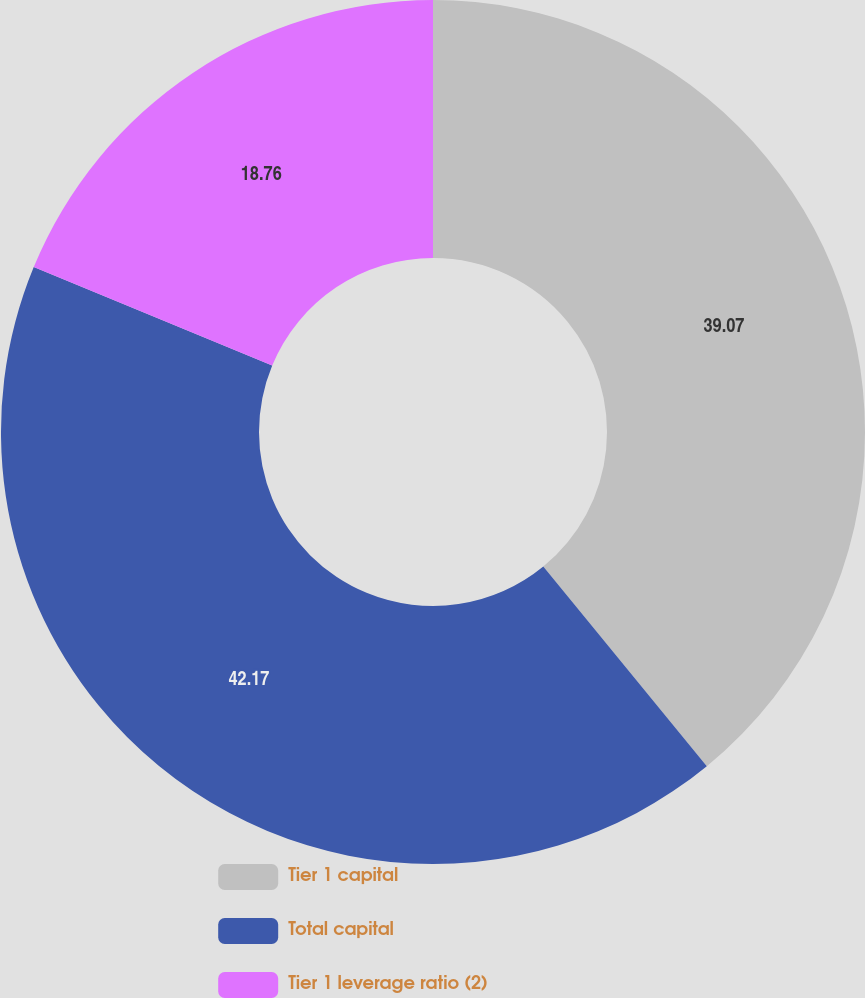Convert chart. <chart><loc_0><loc_0><loc_500><loc_500><pie_chart><fcel>Tier 1 capital<fcel>Total capital<fcel>Tier 1 leverage ratio (2)<nl><fcel>39.07%<fcel>42.16%<fcel>18.76%<nl></chart> 